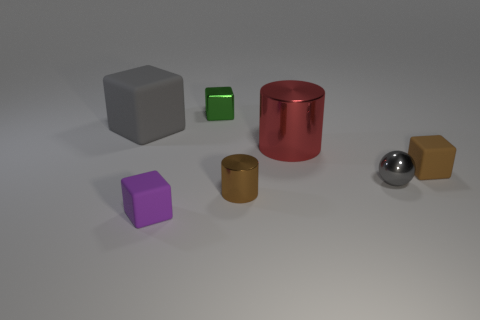Is the number of small brown matte blocks left of the tiny green cube greater than the number of matte blocks on the left side of the tiny brown cylinder?
Offer a terse response. No. There is a tiny object that is behind the cube that is right of the shiny block; what is its color?
Your answer should be very brief. Green. Is there a tiny metal cylinder that has the same color as the ball?
Keep it short and to the point. No. What size is the gray object that is to the left of the block that is in front of the rubber object right of the shiny block?
Your response must be concise. Large. There is a big gray matte object; what shape is it?
Make the answer very short. Cube. What size is the rubber thing that is the same color as the small shiny sphere?
Your answer should be compact. Large. What number of green things are behind the small thing behind the gray block?
Give a very brief answer. 0. What number of other things are made of the same material as the small brown cube?
Your response must be concise. 2. Does the cylinder behind the brown matte object have the same material as the brown thing on the right side of the large metallic thing?
Offer a terse response. No. Are there any other things that are the same shape as the gray shiny object?
Keep it short and to the point. No. 